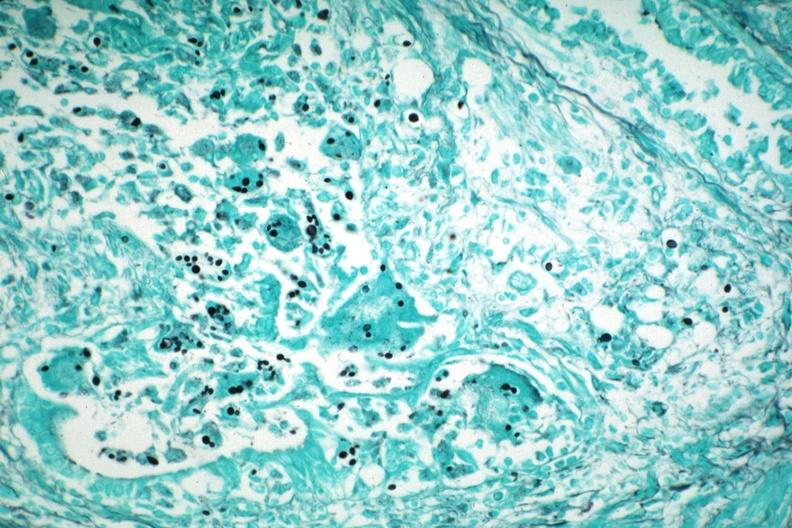what does this image show?
Answer the question using a single word or phrase. Gms illustrates organisms granulomatous prostatitis aids case 